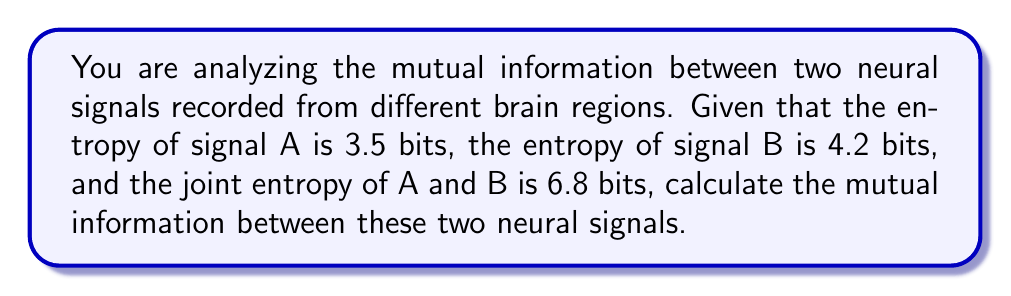Can you answer this question? To solve this problem, we'll use the concept of mutual information from information theory. Mutual information $I(A;B)$ quantifies the amount of information shared between two random variables A and B. It can be calculated using the following formula:

$$I(A;B) = H(A) + H(B) - H(A,B)$$

Where:
$H(A)$ is the entropy of signal A
$H(B)$ is the entropy of signal B
$H(A,B)$ is the joint entropy of signals A and B

Given:
$H(A) = 3.5$ bits
$H(B) = 4.2$ bits
$H(A,B) = 6.8$ bits

Let's substitute these values into the formula:

$$I(A;B) = H(A) + H(B) - H(A,B)$$
$$I(A;B) = 3.5 + 4.2 - 6.8$$
$$I(A;B) = 7.7 - 6.8$$
$$I(A;B) = 0.9$$

Therefore, the mutual information between the two neural signals is 0.9 bits.

This result indicates that there is some degree of shared information between the two neural signals, which could suggest a functional relationship or communication between the two brain regions. In MATLAB, you could use functions from the Information Theory Toolbox to perform similar calculations on actual neural data.
Answer: $I(A;B) = 0.9$ bits 